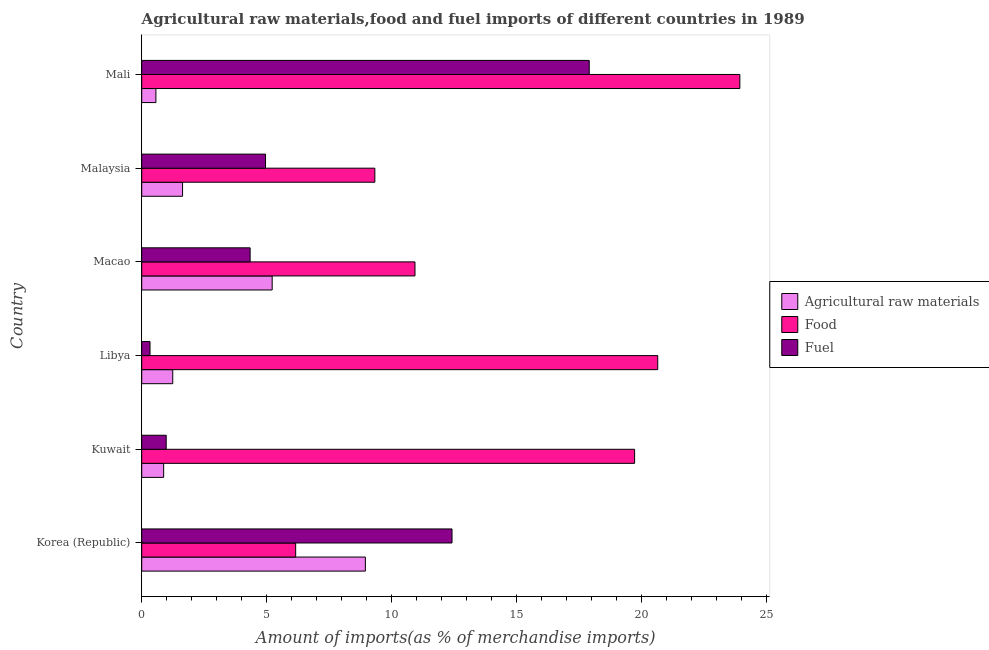Are the number of bars per tick equal to the number of legend labels?
Keep it short and to the point. Yes. How many bars are there on the 5th tick from the top?
Make the answer very short. 3. How many bars are there on the 3rd tick from the bottom?
Provide a short and direct response. 3. What is the label of the 2nd group of bars from the top?
Give a very brief answer. Malaysia. In how many cases, is the number of bars for a given country not equal to the number of legend labels?
Provide a short and direct response. 0. What is the percentage of food imports in Libya?
Give a very brief answer. 20.64. Across all countries, what is the maximum percentage of food imports?
Offer a very short reply. 23.92. Across all countries, what is the minimum percentage of food imports?
Your response must be concise. 6.16. In which country was the percentage of fuel imports maximum?
Offer a very short reply. Mali. What is the total percentage of food imports in the graph?
Keep it short and to the point. 90.68. What is the difference between the percentage of fuel imports in Korea (Republic) and that in Libya?
Your answer should be very brief. 12.08. What is the difference between the percentage of fuel imports in Mali and the percentage of raw materials imports in Macao?
Offer a terse response. 12.68. What is the average percentage of food imports per country?
Your answer should be compact. 15.11. What is the difference between the percentage of fuel imports and percentage of food imports in Kuwait?
Make the answer very short. -18.73. What is the ratio of the percentage of fuel imports in Kuwait to that in Libya?
Make the answer very short. 2.95. What is the difference between the highest and the second highest percentage of raw materials imports?
Ensure brevity in your answer.  3.73. What is the difference between the highest and the lowest percentage of food imports?
Offer a very short reply. 17.76. What does the 3rd bar from the top in Korea (Republic) represents?
Your response must be concise. Agricultural raw materials. What does the 2nd bar from the bottom in Korea (Republic) represents?
Offer a terse response. Food. Is it the case that in every country, the sum of the percentage of raw materials imports and percentage of food imports is greater than the percentage of fuel imports?
Offer a terse response. Yes. How many bars are there?
Provide a succinct answer. 18. Are all the bars in the graph horizontal?
Keep it short and to the point. Yes. How many countries are there in the graph?
Provide a short and direct response. 6. What is the difference between two consecutive major ticks on the X-axis?
Your answer should be very brief. 5. Are the values on the major ticks of X-axis written in scientific E-notation?
Provide a succinct answer. No. Does the graph contain grids?
Ensure brevity in your answer.  No. Where does the legend appear in the graph?
Your response must be concise. Center right. How many legend labels are there?
Your answer should be very brief. 3. What is the title of the graph?
Ensure brevity in your answer.  Agricultural raw materials,food and fuel imports of different countries in 1989. What is the label or title of the X-axis?
Keep it short and to the point. Amount of imports(as % of merchandise imports). What is the Amount of imports(as % of merchandise imports) of Agricultural raw materials in Korea (Republic)?
Keep it short and to the point. 8.95. What is the Amount of imports(as % of merchandise imports) of Food in Korea (Republic)?
Offer a very short reply. 6.16. What is the Amount of imports(as % of merchandise imports) in Fuel in Korea (Republic)?
Provide a succinct answer. 12.41. What is the Amount of imports(as % of merchandise imports) of Agricultural raw materials in Kuwait?
Offer a terse response. 0.88. What is the Amount of imports(as % of merchandise imports) of Food in Kuwait?
Make the answer very short. 19.71. What is the Amount of imports(as % of merchandise imports) of Fuel in Kuwait?
Offer a terse response. 0.98. What is the Amount of imports(as % of merchandise imports) in Agricultural raw materials in Libya?
Your answer should be very brief. 1.24. What is the Amount of imports(as % of merchandise imports) in Food in Libya?
Make the answer very short. 20.64. What is the Amount of imports(as % of merchandise imports) in Fuel in Libya?
Give a very brief answer. 0.33. What is the Amount of imports(as % of merchandise imports) in Agricultural raw materials in Macao?
Offer a very short reply. 5.22. What is the Amount of imports(as % of merchandise imports) of Food in Macao?
Your answer should be compact. 10.93. What is the Amount of imports(as % of merchandise imports) of Fuel in Macao?
Your response must be concise. 4.34. What is the Amount of imports(as % of merchandise imports) of Agricultural raw materials in Malaysia?
Your response must be concise. 1.63. What is the Amount of imports(as % of merchandise imports) of Food in Malaysia?
Ensure brevity in your answer.  9.32. What is the Amount of imports(as % of merchandise imports) of Fuel in Malaysia?
Ensure brevity in your answer.  4.95. What is the Amount of imports(as % of merchandise imports) in Agricultural raw materials in Mali?
Offer a very short reply. 0.57. What is the Amount of imports(as % of merchandise imports) of Food in Mali?
Offer a very short reply. 23.92. What is the Amount of imports(as % of merchandise imports) of Fuel in Mali?
Your answer should be compact. 17.9. Across all countries, what is the maximum Amount of imports(as % of merchandise imports) in Agricultural raw materials?
Make the answer very short. 8.95. Across all countries, what is the maximum Amount of imports(as % of merchandise imports) in Food?
Offer a terse response. 23.92. Across all countries, what is the maximum Amount of imports(as % of merchandise imports) of Fuel?
Make the answer very short. 17.9. Across all countries, what is the minimum Amount of imports(as % of merchandise imports) in Agricultural raw materials?
Provide a succinct answer. 0.57. Across all countries, what is the minimum Amount of imports(as % of merchandise imports) in Food?
Ensure brevity in your answer.  6.16. Across all countries, what is the minimum Amount of imports(as % of merchandise imports) in Fuel?
Offer a terse response. 0.33. What is the total Amount of imports(as % of merchandise imports) of Agricultural raw materials in the graph?
Your answer should be compact. 18.48. What is the total Amount of imports(as % of merchandise imports) of Food in the graph?
Provide a short and direct response. 90.68. What is the total Amount of imports(as % of merchandise imports) of Fuel in the graph?
Offer a very short reply. 40.91. What is the difference between the Amount of imports(as % of merchandise imports) of Agricultural raw materials in Korea (Republic) and that in Kuwait?
Provide a succinct answer. 8.07. What is the difference between the Amount of imports(as % of merchandise imports) of Food in Korea (Republic) and that in Kuwait?
Your response must be concise. -13.56. What is the difference between the Amount of imports(as % of merchandise imports) in Fuel in Korea (Republic) and that in Kuwait?
Ensure brevity in your answer.  11.43. What is the difference between the Amount of imports(as % of merchandise imports) in Agricultural raw materials in Korea (Republic) and that in Libya?
Your answer should be compact. 7.7. What is the difference between the Amount of imports(as % of merchandise imports) of Food in Korea (Republic) and that in Libya?
Make the answer very short. -14.48. What is the difference between the Amount of imports(as % of merchandise imports) of Fuel in Korea (Republic) and that in Libya?
Your response must be concise. 12.08. What is the difference between the Amount of imports(as % of merchandise imports) of Agricultural raw materials in Korea (Republic) and that in Macao?
Give a very brief answer. 3.73. What is the difference between the Amount of imports(as % of merchandise imports) of Food in Korea (Republic) and that in Macao?
Your answer should be compact. -4.77. What is the difference between the Amount of imports(as % of merchandise imports) in Fuel in Korea (Republic) and that in Macao?
Your response must be concise. 8.07. What is the difference between the Amount of imports(as % of merchandise imports) in Agricultural raw materials in Korea (Republic) and that in Malaysia?
Provide a short and direct response. 7.31. What is the difference between the Amount of imports(as % of merchandise imports) of Food in Korea (Republic) and that in Malaysia?
Offer a terse response. -3.17. What is the difference between the Amount of imports(as % of merchandise imports) in Fuel in Korea (Republic) and that in Malaysia?
Offer a terse response. 7.46. What is the difference between the Amount of imports(as % of merchandise imports) of Agricultural raw materials in Korea (Republic) and that in Mali?
Offer a terse response. 8.38. What is the difference between the Amount of imports(as % of merchandise imports) in Food in Korea (Republic) and that in Mali?
Your answer should be compact. -17.76. What is the difference between the Amount of imports(as % of merchandise imports) in Fuel in Korea (Republic) and that in Mali?
Offer a terse response. -5.49. What is the difference between the Amount of imports(as % of merchandise imports) of Agricultural raw materials in Kuwait and that in Libya?
Keep it short and to the point. -0.36. What is the difference between the Amount of imports(as % of merchandise imports) of Food in Kuwait and that in Libya?
Give a very brief answer. -0.92. What is the difference between the Amount of imports(as % of merchandise imports) in Fuel in Kuwait and that in Libya?
Your answer should be very brief. 0.65. What is the difference between the Amount of imports(as % of merchandise imports) in Agricultural raw materials in Kuwait and that in Macao?
Your response must be concise. -4.34. What is the difference between the Amount of imports(as % of merchandise imports) of Food in Kuwait and that in Macao?
Give a very brief answer. 8.78. What is the difference between the Amount of imports(as % of merchandise imports) in Fuel in Kuwait and that in Macao?
Your answer should be compact. -3.36. What is the difference between the Amount of imports(as % of merchandise imports) of Agricultural raw materials in Kuwait and that in Malaysia?
Your response must be concise. -0.76. What is the difference between the Amount of imports(as % of merchandise imports) of Food in Kuwait and that in Malaysia?
Your answer should be very brief. 10.39. What is the difference between the Amount of imports(as % of merchandise imports) in Fuel in Kuwait and that in Malaysia?
Offer a terse response. -3.97. What is the difference between the Amount of imports(as % of merchandise imports) of Agricultural raw materials in Kuwait and that in Mali?
Make the answer very short. 0.31. What is the difference between the Amount of imports(as % of merchandise imports) in Food in Kuwait and that in Mali?
Your answer should be compact. -4.21. What is the difference between the Amount of imports(as % of merchandise imports) of Fuel in Kuwait and that in Mali?
Make the answer very short. -16.92. What is the difference between the Amount of imports(as % of merchandise imports) in Agricultural raw materials in Libya and that in Macao?
Give a very brief answer. -3.98. What is the difference between the Amount of imports(as % of merchandise imports) in Food in Libya and that in Macao?
Your answer should be compact. 9.71. What is the difference between the Amount of imports(as % of merchandise imports) of Fuel in Libya and that in Macao?
Keep it short and to the point. -4. What is the difference between the Amount of imports(as % of merchandise imports) in Agricultural raw materials in Libya and that in Malaysia?
Your answer should be very brief. -0.39. What is the difference between the Amount of imports(as % of merchandise imports) of Food in Libya and that in Malaysia?
Offer a very short reply. 11.31. What is the difference between the Amount of imports(as % of merchandise imports) in Fuel in Libya and that in Malaysia?
Keep it short and to the point. -4.62. What is the difference between the Amount of imports(as % of merchandise imports) in Agricultural raw materials in Libya and that in Mali?
Make the answer very short. 0.67. What is the difference between the Amount of imports(as % of merchandise imports) of Food in Libya and that in Mali?
Ensure brevity in your answer.  -3.28. What is the difference between the Amount of imports(as % of merchandise imports) of Fuel in Libya and that in Mali?
Provide a succinct answer. -17.57. What is the difference between the Amount of imports(as % of merchandise imports) in Agricultural raw materials in Macao and that in Malaysia?
Your answer should be very brief. 3.58. What is the difference between the Amount of imports(as % of merchandise imports) of Food in Macao and that in Malaysia?
Keep it short and to the point. 1.61. What is the difference between the Amount of imports(as % of merchandise imports) in Fuel in Macao and that in Malaysia?
Offer a terse response. -0.62. What is the difference between the Amount of imports(as % of merchandise imports) in Agricultural raw materials in Macao and that in Mali?
Ensure brevity in your answer.  4.65. What is the difference between the Amount of imports(as % of merchandise imports) in Food in Macao and that in Mali?
Provide a succinct answer. -12.99. What is the difference between the Amount of imports(as % of merchandise imports) of Fuel in Macao and that in Mali?
Offer a very short reply. -13.56. What is the difference between the Amount of imports(as % of merchandise imports) in Agricultural raw materials in Malaysia and that in Mali?
Offer a terse response. 1.07. What is the difference between the Amount of imports(as % of merchandise imports) in Food in Malaysia and that in Mali?
Offer a very short reply. -14.6. What is the difference between the Amount of imports(as % of merchandise imports) of Fuel in Malaysia and that in Mali?
Ensure brevity in your answer.  -12.95. What is the difference between the Amount of imports(as % of merchandise imports) of Agricultural raw materials in Korea (Republic) and the Amount of imports(as % of merchandise imports) of Food in Kuwait?
Make the answer very short. -10.77. What is the difference between the Amount of imports(as % of merchandise imports) of Agricultural raw materials in Korea (Republic) and the Amount of imports(as % of merchandise imports) of Fuel in Kuwait?
Provide a short and direct response. 7.97. What is the difference between the Amount of imports(as % of merchandise imports) of Food in Korea (Republic) and the Amount of imports(as % of merchandise imports) of Fuel in Kuwait?
Offer a terse response. 5.18. What is the difference between the Amount of imports(as % of merchandise imports) of Agricultural raw materials in Korea (Republic) and the Amount of imports(as % of merchandise imports) of Food in Libya?
Give a very brief answer. -11.69. What is the difference between the Amount of imports(as % of merchandise imports) of Agricultural raw materials in Korea (Republic) and the Amount of imports(as % of merchandise imports) of Fuel in Libya?
Ensure brevity in your answer.  8.61. What is the difference between the Amount of imports(as % of merchandise imports) of Food in Korea (Republic) and the Amount of imports(as % of merchandise imports) of Fuel in Libya?
Offer a very short reply. 5.83. What is the difference between the Amount of imports(as % of merchandise imports) of Agricultural raw materials in Korea (Republic) and the Amount of imports(as % of merchandise imports) of Food in Macao?
Offer a terse response. -1.98. What is the difference between the Amount of imports(as % of merchandise imports) of Agricultural raw materials in Korea (Republic) and the Amount of imports(as % of merchandise imports) of Fuel in Macao?
Keep it short and to the point. 4.61. What is the difference between the Amount of imports(as % of merchandise imports) in Food in Korea (Republic) and the Amount of imports(as % of merchandise imports) in Fuel in Macao?
Keep it short and to the point. 1.82. What is the difference between the Amount of imports(as % of merchandise imports) of Agricultural raw materials in Korea (Republic) and the Amount of imports(as % of merchandise imports) of Food in Malaysia?
Offer a very short reply. -0.38. What is the difference between the Amount of imports(as % of merchandise imports) in Agricultural raw materials in Korea (Republic) and the Amount of imports(as % of merchandise imports) in Fuel in Malaysia?
Offer a very short reply. 3.99. What is the difference between the Amount of imports(as % of merchandise imports) of Food in Korea (Republic) and the Amount of imports(as % of merchandise imports) of Fuel in Malaysia?
Provide a short and direct response. 1.21. What is the difference between the Amount of imports(as % of merchandise imports) in Agricultural raw materials in Korea (Republic) and the Amount of imports(as % of merchandise imports) in Food in Mali?
Your answer should be compact. -14.98. What is the difference between the Amount of imports(as % of merchandise imports) in Agricultural raw materials in Korea (Republic) and the Amount of imports(as % of merchandise imports) in Fuel in Mali?
Make the answer very short. -8.95. What is the difference between the Amount of imports(as % of merchandise imports) in Food in Korea (Republic) and the Amount of imports(as % of merchandise imports) in Fuel in Mali?
Your answer should be very brief. -11.74. What is the difference between the Amount of imports(as % of merchandise imports) in Agricultural raw materials in Kuwait and the Amount of imports(as % of merchandise imports) in Food in Libya?
Your answer should be very brief. -19.76. What is the difference between the Amount of imports(as % of merchandise imports) of Agricultural raw materials in Kuwait and the Amount of imports(as % of merchandise imports) of Fuel in Libya?
Your response must be concise. 0.55. What is the difference between the Amount of imports(as % of merchandise imports) in Food in Kuwait and the Amount of imports(as % of merchandise imports) in Fuel in Libya?
Provide a short and direct response. 19.38. What is the difference between the Amount of imports(as % of merchandise imports) of Agricultural raw materials in Kuwait and the Amount of imports(as % of merchandise imports) of Food in Macao?
Provide a short and direct response. -10.05. What is the difference between the Amount of imports(as % of merchandise imports) of Agricultural raw materials in Kuwait and the Amount of imports(as % of merchandise imports) of Fuel in Macao?
Keep it short and to the point. -3.46. What is the difference between the Amount of imports(as % of merchandise imports) of Food in Kuwait and the Amount of imports(as % of merchandise imports) of Fuel in Macao?
Your answer should be very brief. 15.38. What is the difference between the Amount of imports(as % of merchandise imports) of Agricultural raw materials in Kuwait and the Amount of imports(as % of merchandise imports) of Food in Malaysia?
Keep it short and to the point. -8.45. What is the difference between the Amount of imports(as % of merchandise imports) in Agricultural raw materials in Kuwait and the Amount of imports(as % of merchandise imports) in Fuel in Malaysia?
Make the answer very short. -4.07. What is the difference between the Amount of imports(as % of merchandise imports) of Food in Kuwait and the Amount of imports(as % of merchandise imports) of Fuel in Malaysia?
Ensure brevity in your answer.  14.76. What is the difference between the Amount of imports(as % of merchandise imports) of Agricultural raw materials in Kuwait and the Amount of imports(as % of merchandise imports) of Food in Mali?
Provide a succinct answer. -23.04. What is the difference between the Amount of imports(as % of merchandise imports) of Agricultural raw materials in Kuwait and the Amount of imports(as % of merchandise imports) of Fuel in Mali?
Your response must be concise. -17.02. What is the difference between the Amount of imports(as % of merchandise imports) of Food in Kuwait and the Amount of imports(as % of merchandise imports) of Fuel in Mali?
Make the answer very short. 1.81. What is the difference between the Amount of imports(as % of merchandise imports) of Agricultural raw materials in Libya and the Amount of imports(as % of merchandise imports) of Food in Macao?
Provide a short and direct response. -9.69. What is the difference between the Amount of imports(as % of merchandise imports) of Agricultural raw materials in Libya and the Amount of imports(as % of merchandise imports) of Fuel in Macao?
Provide a short and direct response. -3.09. What is the difference between the Amount of imports(as % of merchandise imports) in Food in Libya and the Amount of imports(as % of merchandise imports) in Fuel in Macao?
Your answer should be compact. 16.3. What is the difference between the Amount of imports(as % of merchandise imports) of Agricultural raw materials in Libya and the Amount of imports(as % of merchandise imports) of Food in Malaysia?
Your response must be concise. -8.08. What is the difference between the Amount of imports(as % of merchandise imports) of Agricultural raw materials in Libya and the Amount of imports(as % of merchandise imports) of Fuel in Malaysia?
Offer a very short reply. -3.71. What is the difference between the Amount of imports(as % of merchandise imports) of Food in Libya and the Amount of imports(as % of merchandise imports) of Fuel in Malaysia?
Your response must be concise. 15.69. What is the difference between the Amount of imports(as % of merchandise imports) of Agricultural raw materials in Libya and the Amount of imports(as % of merchandise imports) of Food in Mali?
Your response must be concise. -22.68. What is the difference between the Amount of imports(as % of merchandise imports) of Agricultural raw materials in Libya and the Amount of imports(as % of merchandise imports) of Fuel in Mali?
Ensure brevity in your answer.  -16.66. What is the difference between the Amount of imports(as % of merchandise imports) in Food in Libya and the Amount of imports(as % of merchandise imports) in Fuel in Mali?
Your answer should be compact. 2.74. What is the difference between the Amount of imports(as % of merchandise imports) of Agricultural raw materials in Macao and the Amount of imports(as % of merchandise imports) of Food in Malaysia?
Offer a very short reply. -4.11. What is the difference between the Amount of imports(as % of merchandise imports) in Agricultural raw materials in Macao and the Amount of imports(as % of merchandise imports) in Fuel in Malaysia?
Give a very brief answer. 0.27. What is the difference between the Amount of imports(as % of merchandise imports) in Food in Macao and the Amount of imports(as % of merchandise imports) in Fuel in Malaysia?
Keep it short and to the point. 5.98. What is the difference between the Amount of imports(as % of merchandise imports) of Agricultural raw materials in Macao and the Amount of imports(as % of merchandise imports) of Food in Mali?
Provide a short and direct response. -18.7. What is the difference between the Amount of imports(as % of merchandise imports) of Agricultural raw materials in Macao and the Amount of imports(as % of merchandise imports) of Fuel in Mali?
Keep it short and to the point. -12.68. What is the difference between the Amount of imports(as % of merchandise imports) of Food in Macao and the Amount of imports(as % of merchandise imports) of Fuel in Mali?
Your answer should be very brief. -6.97. What is the difference between the Amount of imports(as % of merchandise imports) of Agricultural raw materials in Malaysia and the Amount of imports(as % of merchandise imports) of Food in Mali?
Provide a short and direct response. -22.29. What is the difference between the Amount of imports(as % of merchandise imports) in Agricultural raw materials in Malaysia and the Amount of imports(as % of merchandise imports) in Fuel in Mali?
Provide a succinct answer. -16.27. What is the difference between the Amount of imports(as % of merchandise imports) of Food in Malaysia and the Amount of imports(as % of merchandise imports) of Fuel in Mali?
Make the answer very short. -8.58. What is the average Amount of imports(as % of merchandise imports) in Agricultural raw materials per country?
Provide a short and direct response. 3.08. What is the average Amount of imports(as % of merchandise imports) of Food per country?
Your response must be concise. 15.11. What is the average Amount of imports(as % of merchandise imports) of Fuel per country?
Offer a terse response. 6.82. What is the difference between the Amount of imports(as % of merchandise imports) in Agricultural raw materials and Amount of imports(as % of merchandise imports) in Food in Korea (Republic)?
Provide a short and direct response. 2.79. What is the difference between the Amount of imports(as % of merchandise imports) of Agricultural raw materials and Amount of imports(as % of merchandise imports) of Fuel in Korea (Republic)?
Make the answer very short. -3.46. What is the difference between the Amount of imports(as % of merchandise imports) in Food and Amount of imports(as % of merchandise imports) in Fuel in Korea (Republic)?
Make the answer very short. -6.25. What is the difference between the Amount of imports(as % of merchandise imports) of Agricultural raw materials and Amount of imports(as % of merchandise imports) of Food in Kuwait?
Your response must be concise. -18.84. What is the difference between the Amount of imports(as % of merchandise imports) of Agricultural raw materials and Amount of imports(as % of merchandise imports) of Fuel in Kuwait?
Offer a terse response. -0.1. What is the difference between the Amount of imports(as % of merchandise imports) in Food and Amount of imports(as % of merchandise imports) in Fuel in Kuwait?
Offer a very short reply. 18.73. What is the difference between the Amount of imports(as % of merchandise imports) in Agricultural raw materials and Amount of imports(as % of merchandise imports) in Food in Libya?
Provide a succinct answer. -19.4. What is the difference between the Amount of imports(as % of merchandise imports) of Agricultural raw materials and Amount of imports(as % of merchandise imports) of Fuel in Libya?
Offer a very short reply. 0.91. What is the difference between the Amount of imports(as % of merchandise imports) in Food and Amount of imports(as % of merchandise imports) in Fuel in Libya?
Your response must be concise. 20.31. What is the difference between the Amount of imports(as % of merchandise imports) in Agricultural raw materials and Amount of imports(as % of merchandise imports) in Food in Macao?
Your response must be concise. -5.71. What is the difference between the Amount of imports(as % of merchandise imports) of Agricultural raw materials and Amount of imports(as % of merchandise imports) of Fuel in Macao?
Provide a succinct answer. 0.88. What is the difference between the Amount of imports(as % of merchandise imports) in Food and Amount of imports(as % of merchandise imports) in Fuel in Macao?
Keep it short and to the point. 6.59. What is the difference between the Amount of imports(as % of merchandise imports) in Agricultural raw materials and Amount of imports(as % of merchandise imports) in Food in Malaysia?
Your answer should be compact. -7.69. What is the difference between the Amount of imports(as % of merchandise imports) of Agricultural raw materials and Amount of imports(as % of merchandise imports) of Fuel in Malaysia?
Keep it short and to the point. -3.32. What is the difference between the Amount of imports(as % of merchandise imports) in Food and Amount of imports(as % of merchandise imports) in Fuel in Malaysia?
Make the answer very short. 4.37. What is the difference between the Amount of imports(as % of merchandise imports) of Agricultural raw materials and Amount of imports(as % of merchandise imports) of Food in Mali?
Your response must be concise. -23.35. What is the difference between the Amount of imports(as % of merchandise imports) of Agricultural raw materials and Amount of imports(as % of merchandise imports) of Fuel in Mali?
Provide a short and direct response. -17.33. What is the difference between the Amount of imports(as % of merchandise imports) of Food and Amount of imports(as % of merchandise imports) of Fuel in Mali?
Give a very brief answer. 6.02. What is the ratio of the Amount of imports(as % of merchandise imports) of Agricultural raw materials in Korea (Republic) to that in Kuwait?
Your answer should be compact. 10.2. What is the ratio of the Amount of imports(as % of merchandise imports) of Food in Korea (Republic) to that in Kuwait?
Your answer should be compact. 0.31. What is the ratio of the Amount of imports(as % of merchandise imports) in Fuel in Korea (Republic) to that in Kuwait?
Provide a short and direct response. 12.68. What is the ratio of the Amount of imports(as % of merchandise imports) in Agricultural raw materials in Korea (Republic) to that in Libya?
Your response must be concise. 7.21. What is the ratio of the Amount of imports(as % of merchandise imports) in Food in Korea (Republic) to that in Libya?
Provide a short and direct response. 0.3. What is the ratio of the Amount of imports(as % of merchandise imports) in Fuel in Korea (Republic) to that in Libya?
Your answer should be compact. 37.44. What is the ratio of the Amount of imports(as % of merchandise imports) of Agricultural raw materials in Korea (Republic) to that in Macao?
Offer a very short reply. 1.71. What is the ratio of the Amount of imports(as % of merchandise imports) in Food in Korea (Republic) to that in Macao?
Offer a terse response. 0.56. What is the ratio of the Amount of imports(as % of merchandise imports) of Fuel in Korea (Republic) to that in Macao?
Your answer should be very brief. 2.86. What is the ratio of the Amount of imports(as % of merchandise imports) of Agricultural raw materials in Korea (Republic) to that in Malaysia?
Offer a terse response. 5.48. What is the ratio of the Amount of imports(as % of merchandise imports) in Food in Korea (Republic) to that in Malaysia?
Ensure brevity in your answer.  0.66. What is the ratio of the Amount of imports(as % of merchandise imports) in Fuel in Korea (Republic) to that in Malaysia?
Offer a terse response. 2.51. What is the ratio of the Amount of imports(as % of merchandise imports) of Agricultural raw materials in Korea (Republic) to that in Mali?
Keep it short and to the point. 15.76. What is the ratio of the Amount of imports(as % of merchandise imports) in Food in Korea (Republic) to that in Mali?
Your response must be concise. 0.26. What is the ratio of the Amount of imports(as % of merchandise imports) of Fuel in Korea (Republic) to that in Mali?
Provide a short and direct response. 0.69. What is the ratio of the Amount of imports(as % of merchandise imports) of Agricultural raw materials in Kuwait to that in Libya?
Give a very brief answer. 0.71. What is the ratio of the Amount of imports(as % of merchandise imports) in Food in Kuwait to that in Libya?
Your answer should be compact. 0.96. What is the ratio of the Amount of imports(as % of merchandise imports) in Fuel in Kuwait to that in Libya?
Make the answer very short. 2.95. What is the ratio of the Amount of imports(as % of merchandise imports) of Agricultural raw materials in Kuwait to that in Macao?
Make the answer very short. 0.17. What is the ratio of the Amount of imports(as % of merchandise imports) in Food in Kuwait to that in Macao?
Provide a succinct answer. 1.8. What is the ratio of the Amount of imports(as % of merchandise imports) of Fuel in Kuwait to that in Macao?
Offer a very short reply. 0.23. What is the ratio of the Amount of imports(as % of merchandise imports) of Agricultural raw materials in Kuwait to that in Malaysia?
Give a very brief answer. 0.54. What is the ratio of the Amount of imports(as % of merchandise imports) of Food in Kuwait to that in Malaysia?
Provide a short and direct response. 2.11. What is the ratio of the Amount of imports(as % of merchandise imports) in Fuel in Kuwait to that in Malaysia?
Provide a short and direct response. 0.2. What is the ratio of the Amount of imports(as % of merchandise imports) of Agricultural raw materials in Kuwait to that in Mali?
Make the answer very short. 1.55. What is the ratio of the Amount of imports(as % of merchandise imports) of Food in Kuwait to that in Mali?
Provide a succinct answer. 0.82. What is the ratio of the Amount of imports(as % of merchandise imports) of Fuel in Kuwait to that in Mali?
Your answer should be very brief. 0.05. What is the ratio of the Amount of imports(as % of merchandise imports) in Agricultural raw materials in Libya to that in Macao?
Offer a very short reply. 0.24. What is the ratio of the Amount of imports(as % of merchandise imports) in Food in Libya to that in Macao?
Ensure brevity in your answer.  1.89. What is the ratio of the Amount of imports(as % of merchandise imports) of Fuel in Libya to that in Macao?
Your answer should be compact. 0.08. What is the ratio of the Amount of imports(as % of merchandise imports) of Agricultural raw materials in Libya to that in Malaysia?
Give a very brief answer. 0.76. What is the ratio of the Amount of imports(as % of merchandise imports) in Food in Libya to that in Malaysia?
Offer a terse response. 2.21. What is the ratio of the Amount of imports(as % of merchandise imports) of Fuel in Libya to that in Malaysia?
Your answer should be very brief. 0.07. What is the ratio of the Amount of imports(as % of merchandise imports) of Agricultural raw materials in Libya to that in Mali?
Keep it short and to the point. 2.19. What is the ratio of the Amount of imports(as % of merchandise imports) in Food in Libya to that in Mali?
Your answer should be very brief. 0.86. What is the ratio of the Amount of imports(as % of merchandise imports) in Fuel in Libya to that in Mali?
Offer a very short reply. 0.02. What is the ratio of the Amount of imports(as % of merchandise imports) of Agricultural raw materials in Macao to that in Malaysia?
Keep it short and to the point. 3.19. What is the ratio of the Amount of imports(as % of merchandise imports) of Food in Macao to that in Malaysia?
Make the answer very short. 1.17. What is the ratio of the Amount of imports(as % of merchandise imports) in Fuel in Macao to that in Malaysia?
Offer a very short reply. 0.88. What is the ratio of the Amount of imports(as % of merchandise imports) of Agricultural raw materials in Macao to that in Mali?
Offer a very short reply. 9.19. What is the ratio of the Amount of imports(as % of merchandise imports) in Food in Macao to that in Mali?
Provide a short and direct response. 0.46. What is the ratio of the Amount of imports(as % of merchandise imports) in Fuel in Macao to that in Mali?
Give a very brief answer. 0.24. What is the ratio of the Amount of imports(as % of merchandise imports) of Agricultural raw materials in Malaysia to that in Mali?
Provide a short and direct response. 2.88. What is the ratio of the Amount of imports(as % of merchandise imports) in Food in Malaysia to that in Mali?
Your response must be concise. 0.39. What is the ratio of the Amount of imports(as % of merchandise imports) of Fuel in Malaysia to that in Mali?
Your response must be concise. 0.28. What is the difference between the highest and the second highest Amount of imports(as % of merchandise imports) in Agricultural raw materials?
Ensure brevity in your answer.  3.73. What is the difference between the highest and the second highest Amount of imports(as % of merchandise imports) of Food?
Give a very brief answer. 3.28. What is the difference between the highest and the second highest Amount of imports(as % of merchandise imports) in Fuel?
Offer a very short reply. 5.49. What is the difference between the highest and the lowest Amount of imports(as % of merchandise imports) of Agricultural raw materials?
Your answer should be compact. 8.38. What is the difference between the highest and the lowest Amount of imports(as % of merchandise imports) in Food?
Make the answer very short. 17.76. What is the difference between the highest and the lowest Amount of imports(as % of merchandise imports) of Fuel?
Provide a succinct answer. 17.57. 